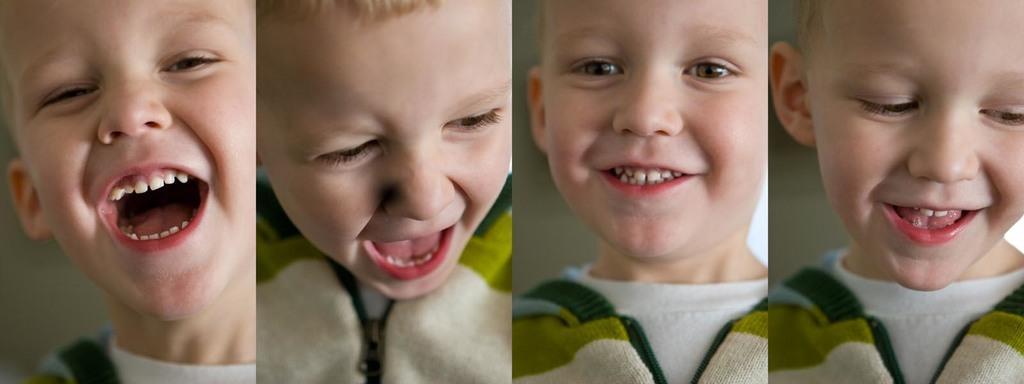In one or two sentences, can you explain what this image depicts? In the image there is a collage of the same boy with different expressions. 